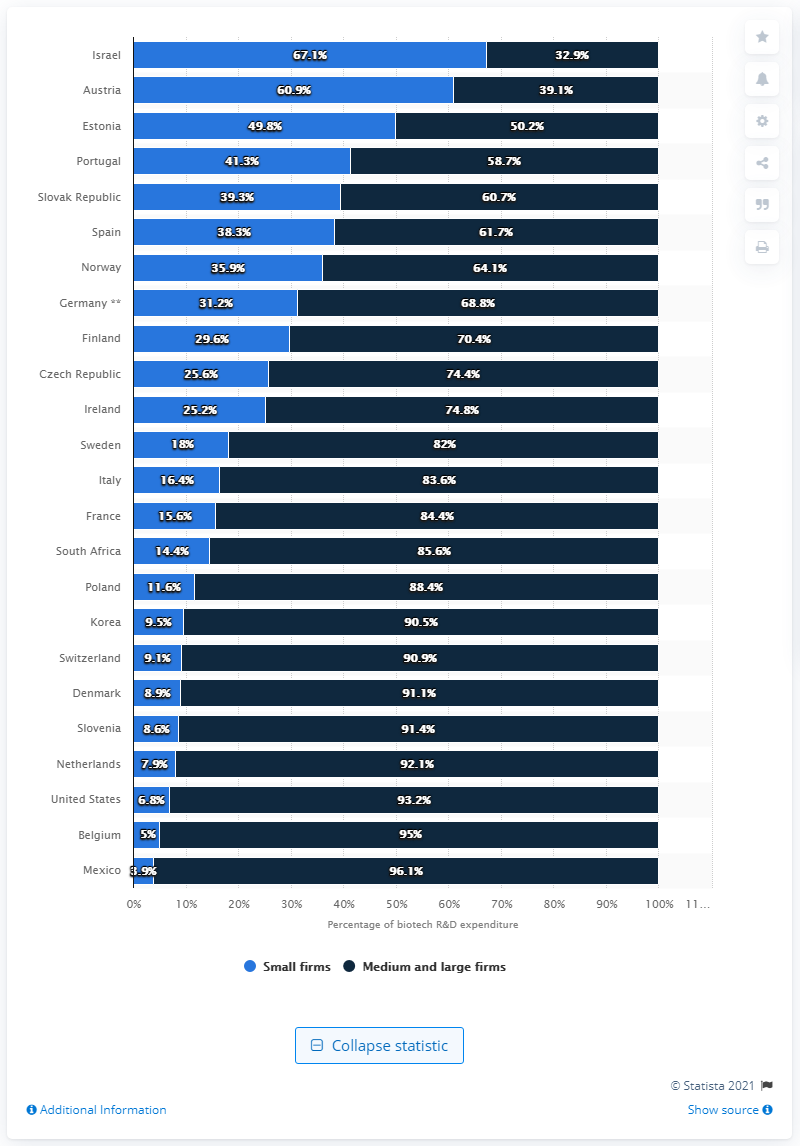Outline some significant characteristics in this image. In 2014, small biotechnology companies in Austria accounted for 60.9% of the country's total expenditures on biotechnology research and development. 